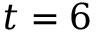<formula> <loc_0><loc_0><loc_500><loc_500>t = 6</formula> 